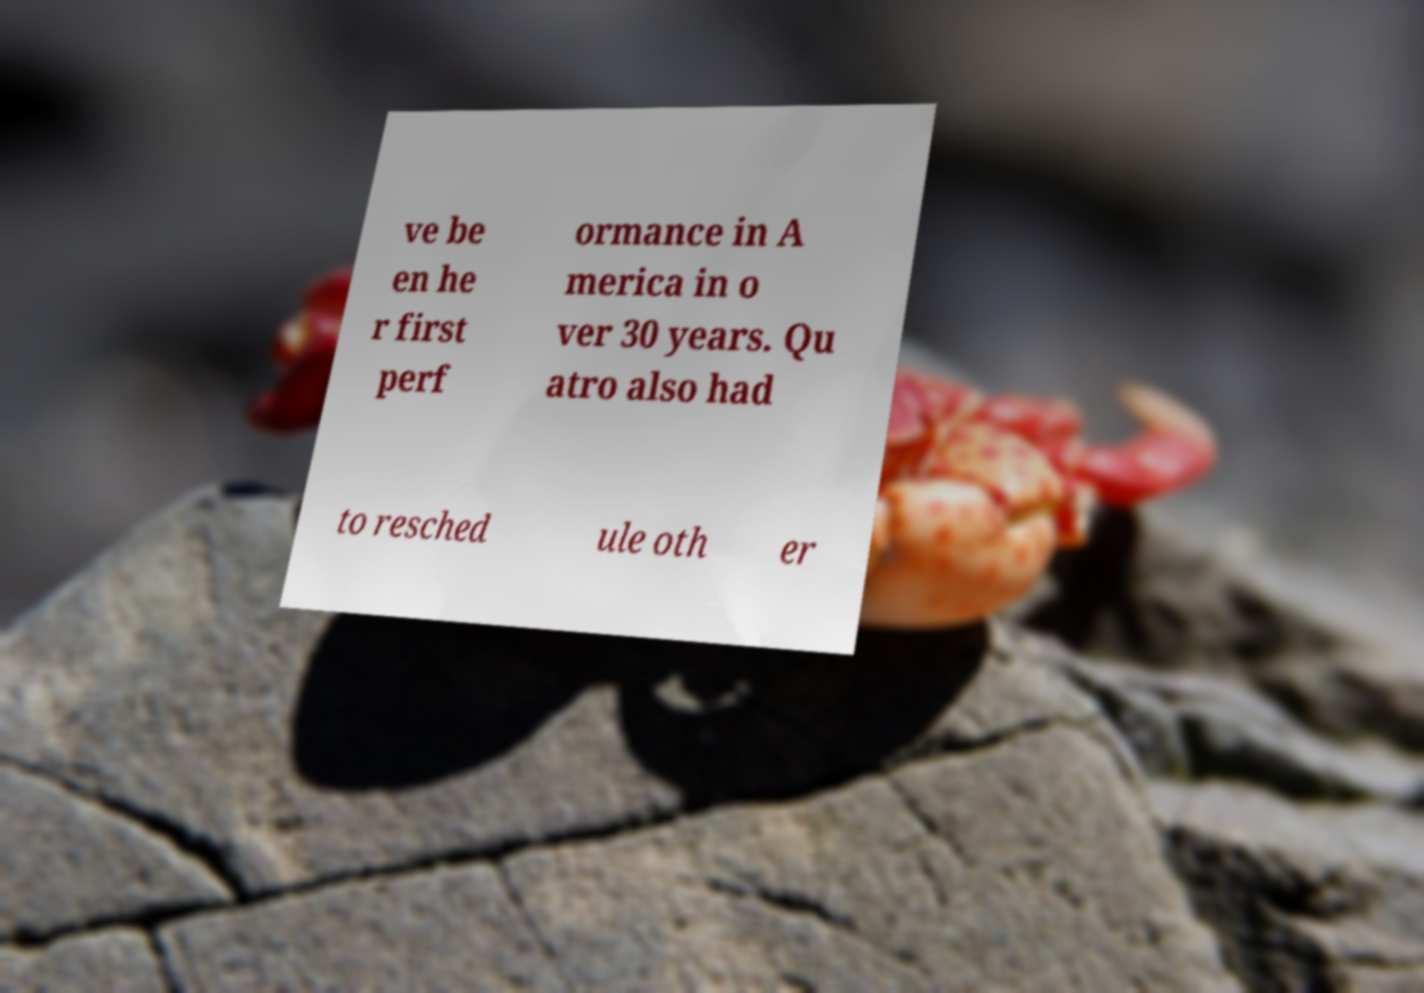I need the written content from this picture converted into text. Can you do that? ve be en he r first perf ormance in A merica in o ver 30 years. Qu atro also had to resched ule oth er 